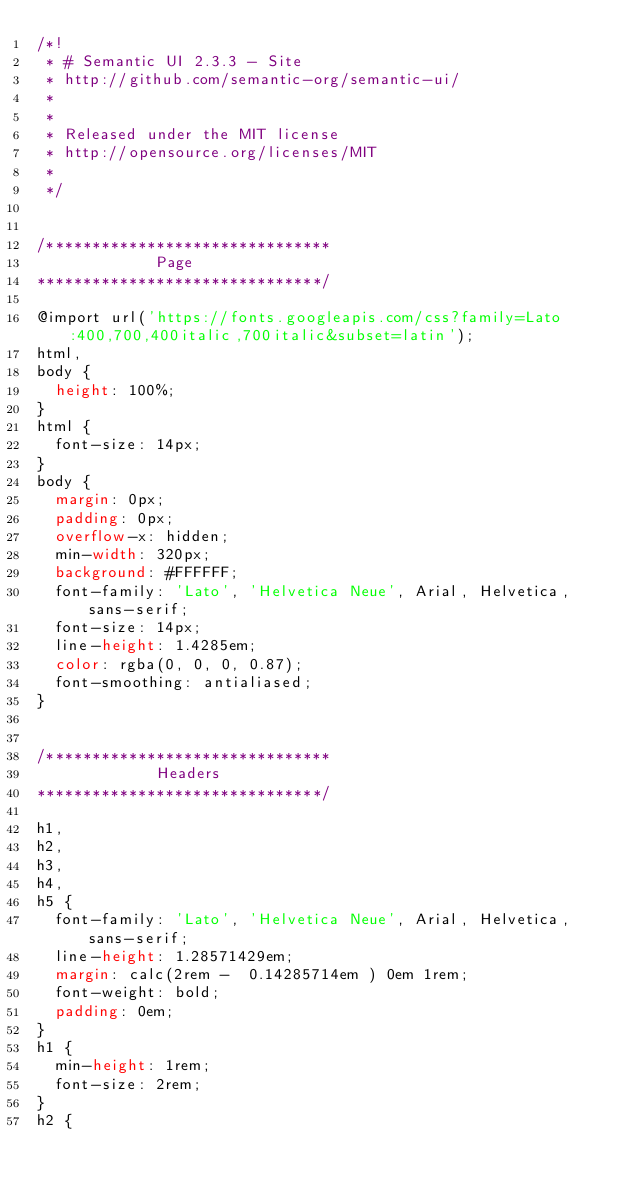Convert code to text. <code><loc_0><loc_0><loc_500><loc_500><_CSS_>/*!
 * # Semantic UI 2.3.3 - Site
 * http://github.com/semantic-org/semantic-ui/
 *
 *
 * Released under the MIT license
 * http://opensource.org/licenses/MIT
 *
 */


/*******************************
             Page
*******************************/

@import url('https://fonts.googleapis.com/css?family=Lato:400,700,400italic,700italic&subset=latin');
html,
body {
  height: 100%;
}
html {
  font-size: 14px;
}
body {
  margin: 0px;
  padding: 0px;
  overflow-x: hidden;
  min-width: 320px;
  background: #FFFFFF;
  font-family: 'Lato', 'Helvetica Neue', Arial, Helvetica, sans-serif;
  font-size: 14px;
  line-height: 1.4285em;
  color: rgba(0, 0, 0, 0.87);
  font-smoothing: antialiased;
}


/*******************************
             Headers
*******************************/

h1,
h2,
h3,
h4,
h5 {
  font-family: 'Lato', 'Helvetica Neue', Arial, Helvetica, sans-serif;
  line-height: 1.28571429em;
  margin: calc(2rem -  0.14285714em ) 0em 1rem;
  font-weight: bold;
  padding: 0em;
}
h1 {
  min-height: 1rem;
  font-size: 2rem;
}
h2 {</code> 